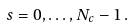<formula> <loc_0><loc_0><loc_500><loc_500>\ s = 0 , \dots , N _ { c } - 1 \, .</formula> 